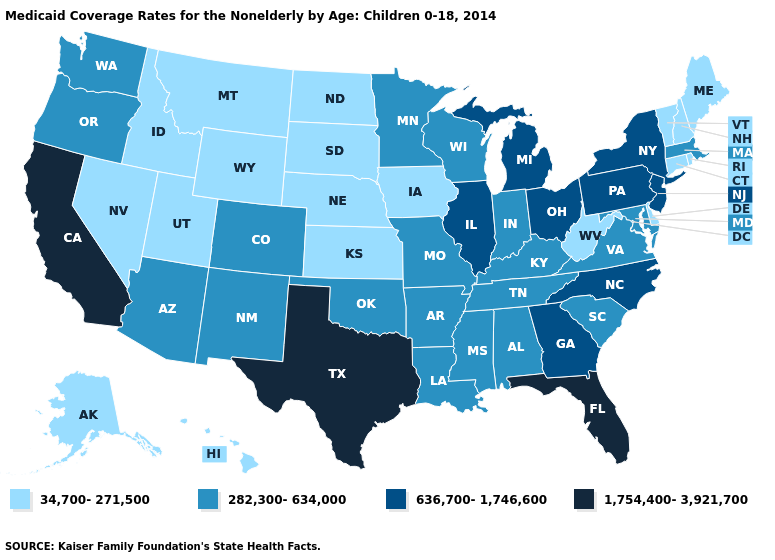Does the map have missing data?
Quick response, please. No. What is the value of Kentucky?
Keep it brief. 282,300-634,000. Does West Virginia have the lowest value in the South?
Quick response, please. Yes. What is the value of Maryland?
Be succinct. 282,300-634,000. Does New York have the lowest value in the USA?
Be succinct. No. What is the value of New Mexico?
Answer briefly. 282,300-634,000. Name the states that have a value in the range 636,700-1,746,600?
Write a very short answer. Georgia, Illinois, Michigan, New Jersey, New York, North Carolina, Ohio, Pennsylvania. Which states have the highest value in the USA?
Be succinct. California, Florida, Texas. Name the states that have a value in the range 282,300-634,000?
Be succinct. Alabama, Arizona, Arkansas, Colorado, Indiana, Kentucky, Louisiana, Maryland, Massachusetts, Minnesota, Mississippi, Missouri, New Mexico, Oklahoma, Oregon, South Carolina, Tennessee, Virginia, Washington, Wisconsin. Name the states that have a value in the range 282,300-634,000?
Keep it brief. Alabama, Arizona, Arkansas, Colorado, Indiana, Kentucky, Louisiana, Maryland, Massachusetts, Minnesota, Mississippi, Missouri, New Mexico, Oklahoma, Oregon, South Carolina, Tennessee, Virginia, Washington, Wisconsin. What is the value of Indiana?
Concise answer only. 282,300-634,000. Among the states that border North Dakota , which have the lowest value?
Be succinct. Montana, South Dakota. Name the states that have a value in the range 1,754,400-3,921,700?
Write a very short answer. California, Florida, Texas. Name the states that have a value in the range 636,700-1,746,600?
Concise answer only. Georgia, Illinois, Michigan, New Jersey, New York, North Carolina, Ohio, Pennsylvania. What is the lowest value in the USA?
Concise answer only. 34,700-271,500. 